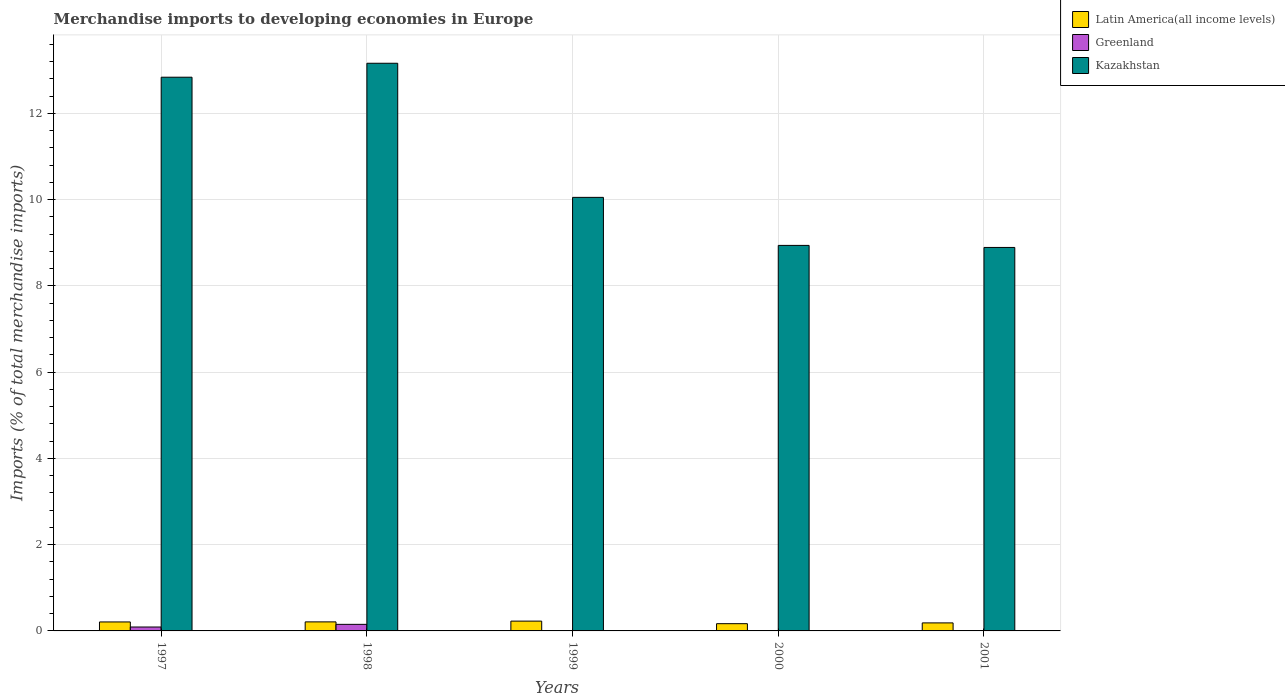Are the number of bars per tick equal to the number of legend labels?
Your response must be concise. Yes. Are the number of bars on each tick of the X-axis equal?
Your response must be concise. Yes. In how many cases, is the number of bars for a given year not equal to the number of legend labels?
Make the answer very short. 0. What is the percentage total merchandise imports in Kazakhstan in 2001?
Offer a terse response. 8.89. Across all years, what is the maximum percentage total merchandise imports in Greenland?
Your answer should be very brief. 0.15. Across all years, what is the minimum percentage total merchandise imports in Latin America(all income levels)?
Your response must be concise. 0.17. What is the total percentage total merchandise imports in Latin America(all income levels) in the graph?
Make the answer very short. 1. What is the difference between the percentage total merchandise imports in Latin America(all income levels) in 1997 and that in 2000?
Ensure brevity in your answer.  0.04. What is the difference between the percentage total merchandise imports in Kazakhstan in 1998 and the percentage total merchandise imports in Latin America(all income levels) in 1999?
Ensure brevity in your answer.  12.94. What is the average percentage total merchandise imports in Latin America(all income levels) per year?
Your answer should be compact. 0.2. In the year 1997, what is the difference between the percentage total merchandise imports in Kazakhstan and percentage total merchandise imports in Latin America(all income levels)?
Give a very brief answer. 12.63. What is the ratio of the percentage total merchandise imports in Kazakhstan in 1999 to that in 2001?
Give a very brief answer. 1.13. What is the difference between the highest and the second highest percentage total merchandise imports in Greenland?
Offer a terse response. 0.06. What is the difference between the highest and the lowest percentage total merchandise imports in Greenland?
Your answer should be compact. 0.15. What does the 3rd bar from the left in 1999 represents?
Offer a terse response. Kazakhstan. What does the 3rd bar from the right in 1999 represents?
Offer a terse response. Latin America(all income levels). How many bars are there?
Offer a very short reply. 15. How many years are there in the graph?
Offer a very short reply. 5. What is the difference between two consecutive major ticks on the Y-axis?
Make the answer very short. 2. Are the values on the major ticks of Y-axis written in scientific E-notation?
Your answer should be very brief. No. Does the graph contain grids?
Ensure brevity in your answer.  Yes. Where does the legend appear in the graph?
Provide a short and direct response. Top right. How many legend labels are there?
Ensure brevity in your answer.  3. How are the legend labels stacked?
Your response must be concise. Vertical. What is the title of the graph?
Make the answer very short. Merchandise imports to developing economies in Europe. What is the label or title of the X-axis?
Your response must be concise. Years. What is the label or title of the Y-axis?
Make the answer very short. Imports (% of total merchandise imports). What is the Imports (% of total merchandise imports) in Latin America(all income levels) in 1997?
Provide a short and direct response. 0.21. What is the Imports (% of total merchandise imports) of Greenland in 1997?
Ensure brevity in your answer.  0.09. What is the Imports (% of total merchandise imports) in Kazakhstan in 1997?
Your answer should be very brief. 12.84. What is the Imports (% of total merchandise imports) in Latin America(all income levels) in 1998?
Your answer should be compact. 0.21. What is the Imports (% of total merchandise imports) of Greenland in 1998?
Provide a short and direct response. 0.15. What is the Imports (% of total merchandise imports) of Kazakhstan in 1998?
Make the answer very short. 13.16. What is the Imports (% of total merchandise imports) in Latin America(all income levels) in 1999?
Your response must be concise. 0.23. What is the Imports (% of total merchandise imports) in Greenland in 1999?
Your response must be concise. 0. What is the Imports (% of total merchandise imports) of Kazakhstan in 1999?
Your response must be concise. 10.05. What is the Imports (% of total merchandise imports) of Latin America(all income levels) in 2000?
Provide a short and direct response. 0.17. What is the Imports (% of total merchandise imports) in Greenland in 2000?
Keep it short and to the point. 0. What is the Imports (% of total merchandise imports) of Kazakhstan in 2000?
Offer a terse response. 8.94. What is the Imports (% of total merchandise imports) of Latin America(all income levels) in 2001?
Provide a short and direct response. 0.19. What is the Imports (% of total merchandise imports) of Greenland in 2001?
Ensure brevity in your answer.  0. What is the Imports (% of total merchandise imports) of Kazakhstan in 2001?
Your answer should be very brief. 8.89. Across all years, what is the maximum Imports (% of total merchandise imports) in Latin America(all income levels)?
Your answer should be very brief. 0.23. Across all years, what is the maximum Imports (% of total merchandise imports) in Greenland?
Make the answer very short. 0.15. Across all years, what is the maximum Imports (% of total merchandise imports) of Kazakhstan?
Make the answer very short. 13.16. Across all years, what is the minimum Imports (% of total merchandise imports) in Latin America(all income levels)?
Your answer should be very brief. 0.17. Across all years, what is the minimum Imports (% of total merchandise imports) in Greenland?
Your response must be concise. 0. Across all years, what is the minimum Imports (% of total merchandise imports) in Kazakhstan?
Provide a succinct answer. 8.89. What is the total Imports (% of total merchandise imports) in Latin America(all income levels) in the graph?
Provide a short and direct response. 1. What is the total Imports (% of total merchandise imports) in Greenland in the graph?
Provide a succinct answer. 0.25. What is the total Imports (% of total merchandise imports) of Kazakhstan in the graph?
Your response must be concise. 53.89. What is the difference between the Imports (% of total merchandise imports) in Latin America(all income levels) in 1997 and that in 1998?
Offer a terse response. -0. What is the difference between the Imports (% of total merchandise imports) in Greenland in 1997 and that in 1998?
Give a very brief answer. -0.06. What is the difference between the Imports (% of total merchandise imports) of Kazakhstan in 1997 and that in 1998?
Your answer should be compact. -0.32. What is the difference between the Imports (% of total merchandise imports) of Latin America(all income levels) in 1997 and that in 1999?
Offer a terse response. -0.02. What is the difference between the Imports (% of total merchandise imports) of Greenland in 1997 and that in 1999?
Offer a terse response. 0.09. What is the difference between the Imports (% of total merchandise imports) in Kazakhstan in 1997 and that in 1999?
Keep it short and to the point. 2.79. What is the difference between the Imports (% of total merchandise imports) of Latin America(all income levels) in 1997 and that in 2000?
Give a very brief answer. 0.04. What is the difference between the Imports (% of total merchandise imports) of Greenland in 1997 and that in 2000?
Ensure brevity in your answer.  0.09. What is the difference between the Imports (% of total merchandise imports) of Kazakhstan in 1997 and that in 2000?
Your response must be concise. 3.9. What is the difference between the Imports (% of total merchandise imports) of Latin America(all income levels) in 1997 and that in 2001?
Provide a succinct answer. 0.02. What is the difference between the Imports (% of total merchandise imports) of Greenland in 1997 and that in 2001?
Your answer should be very brief. 0.09. What is the difference between the Imports (% of total merchandise imports) of Kazakhstan in 1997 and that in 2001?
Your answer should be very brief. 3.95. What is the difference between the Imports (% of total merchandise imports) in Latin America(all income levels) in 1998 and that in 1999?
Offer a terse response. -0.02. What is the difference between the Imports (% of total merchandise imports) of Greenland in 1998 and that in 1999?
Your answer should be compact. 0.15. What is the difference between the Imports (% of total merchandise imports) of Kazakhstan in 1998 and that in 1999?
Provide a succinct answer. 3.11. What is the difference between the Imports (% of total merchandise imports) of Latin America(all income levels) in 1998 and that in 2000?
Ensure brevity in your answer.  0.04. What is the difference between the Imports (% of total merchandise imports) of Kazakhstan in 1998 and that in 2000?
Make the answer very short. 4.22. What is the difference between the Imports (% of total merchandise imports) in Latin America(all income levels) in 1998 and that in 2001?
Ensure brevity in your answer.  0.02. What is the difference between the Imports (% of total merchandise imports) of Greenland in 1998 and that in 2001?
Keep it short and to the point. 0.15. What is the difference between the Imports (% of total merchandise imports) in Kazakhstan in 1998 and that in 2001?
Make the answer very short. 4.27. What is the difference between the Imports (% of total merchandise imports) of Latin America(all income levels) in 1999 and that in 2000?
Provide a succinct answer. 0.06. What is the difference between the Imports (% of total merchandise imports) of Greenland in 1999 and that in 2000?
Keep it short and to the point. 0. What is the difference between the Imports (% of total merchandise imports) of Kazakhstan in 1999 and that in 2000?
Make the answer very short. 1.11. What is the difference between the Imports (% of total merchandise imports) of Latin America(all income levels) in 1999 and that in 2001?
Ensure brevity in your answer.  0.04. What is the difference between the Imports (% of total merchandise imports) in Greenland in 1999 and that in 2001?
Your answer should be very brief. 0. What is the difference between the Imports (% of total merchandise imports) in Kazakhstan in 1999 and that in 2001?
Make the answer very short. 1.16. What is the difference between the Imports (% of total merchandise imports) of Latin America(all income levels) in 2000 and that in 2001?
Offer a very short reply. -0.02. What is the difference between the Imports (% of total merchandise imports) of Greenland in 2000 and that in 2001?
Your answer should be compact. -0. What is the difference between the Imports (% of total merchandise imports) of Kazakhstan in 2000 and that in 2001?
Ensure brevity in your answer.  0.05. What is the difference between the Imports (% of total merchandise imports) in Latin America(all income levels) in 1997 and the Imports (% of total merchandise imports) in Greenland in 1998?
Your answer should be very brief. 0.06. What is the difference between the Imports (% of total merchandise imports) of Latin America(all income levels) in 1997 and the Imports (% of total merchandise imports) of Kazakhstan in 1998?
Give a very brief answer. -12.95. What is the difference between the Imports (% of total merchandise imports) of Greenland in 1997 and the Imports (% of total merchandise imports) of Kazakhstan in 1998?
Give a very brief answer. -13.07. What is the difference between the Imports (% of total merchandise imports) in Latin America(all income levels) in 1997 and the Imports (% of total merchandise imports) in Greenland in 1999?
Provide a short and direct response. 0.2. What is the difference between the Imports (% of total merchandise imports) in Latin America(all income levels) in 1997 and the Imports (% of total merchandise imports) in Kazakhstan in 1999?
Provide a succinct answer. -9.84. What is the difference between the Imports (% of total merchandise imports) in Greenland in 1997 and the Imports (% of total merchandise imports) in Kazakhstan in 1999?
Make the answer very short. -9.96. What is the difference between the Imports (% of total merchandise imports) in Latin America(all income levels) in 1997 and the Imports (% of total merchandise imports) in Greenland in 2000?
Provide a short and direct response. 0.21. What is the difference between the Imports (% of total merchandise imports) in Latin America(all income levels) in 1997 and the Imports (% of total merchandise imports) in Kazakhstan in 2000?
Provide a succinct answer. -8.73. What is the difference between the Imports (% of total merchandise imports) of Greenland in 1997 and the Imports (% of total merchandise imports) of Kazakhstan in 2000?
Your answer should be compact. -8.85. What is the difference between the Imports (% of total merchandise imports) of Latin America(all income levels) in 1997 and the Imports (% of total merchandise imports) of Greenland in 2001?
Your response must be concise. 0.21. What is the difference between the Imports (% of total merchandise imports) in Latin America(all income levels) in 1997 and the Imports (% of total merchandise imports) in Kazakhstan in 2001?
Keep it short and to the point. -8.68. What is the difference between the Imports (% of total merchandise imports) of Greenland in 1997 and the Imports (% of total merchandise imports) of Kazakhstan in 2001?
Provide a succinct answer. -8.8. What is the difference between the Imports (% of total merchandise imports) of Latin America(all income levels) in 1998 and the Imports (% of total merchandise imports) of Greenland in 1999?
Provide a short and direct response. 0.21. What is the difference between the Imports (% of total merchandise imports) of Latin America(all income levels) in 1998 and the Imports (% of total merchandise imports) of Kazakhstan in 1999?
Your answer should be very brief. -9.84. What is the difference between the Imports (% of total merchandise imports) in Greenland in 1998 and the Imports (% of total merchandise imports) in Kazakhstan in 1999?
Your answer should be very brief. -9.9. What is the difference between the Imports (% of total merchandise imports) of Latin America(all income levels) in 1998 and the Imports (% of total merchandise imports) of Greenland in 2000?
Ensure brevity in your answer.  0.21. What is the difference between the Imports (% of total merchandise imports) in Latin America(all income levels) in 1998 and the Imports (% of total merchandise imports) in Kazakhstan in 2000?
Your answer should be compact. -8.73. What is the difference between the Imports (% of total merchandise imports) of Greenland in 1998 and the Imports (% of total merchandise imports) of Kazakhstan in 2000?
Your answer should be compact. -8.79. What is the difference between the Imports (% of total merchandise imports) in Latin America(all income levels) in 1998 and the Imports (% of total merchandise imports) in Greenland in 2001?
Keep it short and to the point. 0.21. What is the difference between the Imports (% of total merchandise imports) in Latin America(all income levels) in 1998 and the Imports (% of total merchandise imports) in Kazakhstan in 2001?
Offer a terse response. -8.68. What is the difference between the Imports (% of total merchandise imports) in Greenland in 1998 and the Imports (% of total merchandise imports) in Kazakhstan in 2001?
Provide a succinct answer. -8.74. What is the difference between the Imports (% of total merchandise imports) in Latin America(all income levels) in 1999 and the Imports (% of total merchandise imports) in Greenland in 2000?
Provide a succinct answer. 0.23. What is the difference between the Imports (% of total merchandise imports) of Latin America(all income levels) in 1999 and the Imports (% of total merchandise imports) of Kazakhstan in 2000?
Provide a succinct answer. -8.71. What is the difference between the Imports (% of total merchandise imports) in Greenland in 1999 and the Imports (% of total merchandise imports) in Kazakhstan in 2000?
Give a very brief answer. -8.94. What is the difference between the Imports (% of total merchandise imports) of Latin America(all income levels) in 1999 and the Imports (% of total merchandise imports) of Greenland in 2001?
Your response must be concise. 0.22. What is the difference between the Imports (% of total merchandise imports) of Latin America(all income levels) in 1999 and the Imports (% of total merchandise imports) of Kazakhstan in 2001?
Offer a very short reply. -8.66. What is the difference between the Imports (% of total merchandise imports) in Greenland in 1999 and the Imports (% of total merchandise imports) in Kazakhstan in 2001?
Offer a very short reply. -8.89. What is the difference between the Imports (% of total merchandise imports) of Latin America(all income levels) in 2000 and the Imports (% of total merchandise imports) of Greenland in 2001?
Your answer should be compact. 0.17. What is the difference between the Imports (% of total merchandise imports) in Latin America(all income levels) in 2000 and the Imports (% of total merchandise imports) in Kazakhstan in 2001?
Ensure brevity in your answer.  -8.72. What is the difference between the Imports (% of total merchandise imports) in Greenland in 2000 and the Imports (% of total merchandise imports) in Kazakhstan in 2001?
Ensure brevity in your answer.  -8.89. What is the average Imports (% of total merchandise imports) in Latin America(all income levels) per year?
Provide a succinct answer. 0.2. What is the average Imports (% of total merchandise imports) of Greenland per year?
Offer a very short reply. 0.05. What is the average Imports (% of total merchandise imports) of Kazakhstan per year?
Offer a terse response. 10.78. In the year 1997, what is the difference between the Imports (% of total merchandise imports) in Latin America(all income levels) and Imports (% of total merchandise imports) in Greenland?
Make the answer very short. 0.12. In the year 1997, what is the difference between the Imports (% of total merchandise imports) in Latin America(all income levels) and Imports (% of total merchandise imports) in Kazakhstan?
Provide a succinct answer. -12.63. In the year 1997, what is the difference between the Imports (% of total merchandise imports) in Greenland and Imports (% of total merchandise imports) in Kazakhstan?
Make the answer very short. -12.75. In the year 1998, what is the difference between the Imports (% of total merchandise imports) in Latin America(all income levels) and Imports (% of total merchandise imports) in Greenland?
Your answer should be very brief. 0.06. In the year 1998, what is the difference between the Imports (% of total merchandise imports) in Latin America(all income levels) and Imports (% of total merchandise imports) in Kazakhstan?
Ensure brevity in your answer.  -12.95. In the year 1998, what is the difference between the Imports (% of total merchandise imports) of Greenland and Imports (% of total merchandise imports) of Kazakhstan?
Ensure brevity in your answer.  -13.01. In the year 1999, what is the difference between the Imports (% of total merchandise imports) in Latin America(all income levels) and Imports (% of total merchandise imports) in Greenland?
Provide a succinct answer. 0.22. In the year 1999, what is the difference between the Imports (% of total merchandise imports) in Latin America(all income levels) and Imports (% of total merchandise imports) in Kazakhstan?
Your answer should be compact. -9.83. In the year 1999, what is the difference between the Imports (% of total merchandise imports) in Greenland and Imports (% of total merchandise imports) in Kazakhstan?
Ensure brevity in your answer.  -10.05. In the year 2000, what is the difference between the Imports (% of total merchandise imports) of Latin America(all income levels) and Imports (% of total merchandise imports) of Greenland?
Provide a short and direct response. 0.17. In the year 2000, what is the difference between the Imports (% of total merchandise imports) of Latin America(all income levels) and Imports (% of total merchandise imports) of Kazakhstan?
Provide a succinct answer. -8.77. In the year 2000, what is the difference between the Imports (% of total merchandise imports) in Greenland and Imports (% of total merchandise imports) in Kazakhstan?
Provide a succinct answer. -8.94. In the year 2001, what is the difference between the Imports (% of total merchandise imports) of Latin America(all income levels) and Imports (% of total merchandise imports) of Greenland?
Offer a terse response. 0.18. In the year 2001, what is the difference between the Imports (% of total merchandise imports) in Latin America(all income levels) and Imports (% of total merchandise imports) in Kazakhstan?
Ensure brevity in your answer.  -8.71. In the year 2001, what is the difference between the Imports (% of total merchandise imports) of Greenland and Imports (% of total merchandise imports) of Kazakhstan?
Offer a very short reply. -8.89. What is the ratio of the Imports (% of total merchandise imports) in Latin America(all income levels) in 1997 to that in 1998?
Keep it short and to the point. 0.99. What is the ratio of the Imports (% of total merchandise imports) in Greenland in 1997 to that in 1998?
Offer a very short reply. 0.6. What is the ratio of the Imports (% of total merchandise imports) in Kazakhstan in 1997 to that in 1998?
Keep it short and to the point. 0.98. What is the ratio of the Imports (% of total merchandise imports) of Latin America(all income levels) in 1997 to that in 1999?
Your response must be concise. 0.91. What is the ratio of the Imports (% of total merchandise imports) of Greenland in 1997 to that in 1999?
Offer a terse response. 21.65. What is the ratio of the Imports (% of total merchandise imports) of Kazakhstan in 1997 to that in 1999?
Keep it short and to the point. 1.28. What is the ratio of the Imports (% of total merchandise imports) of Latin America(all income levels) in 1997 to that in 2000?
Your answer should be compact. 1.24. What is the ratio of the Imports (% of total merchandise imports) in Greenland in 1997 to that in 2000?
Keep it short and to the point. 37.03. What is the ratio of the Imports (% of total merchandise imports) of Kazakhstan in 1997 to that in 2000?
Give a very brief answer. 1.44. What is the ratio of the Imports (% of total merchandise imports) of Latin America(all income levels) in 1997 to that in 2001?
Keep it short and to the point. 1.12. What is the ratio of the Imports (% of total merchandise imports) in Greenland in 1997 to that in 2001?
Offer a very short reply. 34.31. What is the ratio of the Imports (% of total merchandise imports) of Kazakhstan in 1997 to that in 2001?
Make the answer very short. 1.44. What is the ratio of the Imports (% of total merchandise imports) in Latin America(all income levels) in 1998 to that in 1999?
Your answer should be very brief. 0.92. What is the ratio of the Imports (% of total merchandise imports) in Greenland in 1998 to that in 1999?
Your answer should be very brief. 36.33. What is the ratio of the Imports (% of total merchandise imports) of Kazakhstan in 1998 to that in 1999?
Make the answer very short. 1.31. What is the ratio of the Imports (% of total merchandise imports) in Latin America(all income levels) in 1998 to that in 2000?
Offer a very short reply. 1.25. What is the ratio of the Imports (% of total merchandise imports) of Greenland in 1998 to that in 2000?
Your answer should be compact. 62.14. What is the ratio of the Imports (% of total merchandise imports) of Kazakhstan in 1998 to that in 2000?
Give a very brief answer. 1.47. What is the ratio of the Imports (% of total merchandise imports) in Latin America(all income levels) in 1998 to that in 2001?
Your answer should be compact. 1.13. What is the ratio of the Imports (% of total merchandise imports) of Greenland in 1998 to that in 2001?
Make the answer very short. 57.58. What is the ratio of the Imports (% of total merchandise imports) of Kazakhstan in 1998 to that in 2001?
Provide a succinct answer. 1.48. What is the ratio of the Imports (% of total merchandise imports) in Latin America(all income levels) in 1999 to that in 2000?
Your response must be concise. 1.36. What is the ratio of the Imports (% of total merchandise imports) of Greenland in 1999 to that in 2000?
Provide a short and direct response. 1.71. What is the ratio of the Imports (% of total merchandise imports) in Kazakhstan in 1999 to that in 2000?
Offer a very short reply. 1.12. What is the ratio of the Imports (% of total merchandise imports) in Latin America(all income levels) in 1999 to that in 2001?
Offer a very short reply. 1.22. What is the ratio of the Imports (% of total merchandise imports) of Greenland in 1999 to that in 2001?
Make the answer very short. 1.58. What is the ratio of the Imports (% of total merchandise imports) of Kazakhstan in 1999 to that in 2001?
Offer a terse response. 1.13. What is the ratio of the Imports (% of total merchandise imports) of Latin America(all income levels) in 2000 to that in 2001?
Keep it short and to the point. 0.9. What is the ratio of the Imports (% of total merchandise imports) in Greenland in 2000 to that in 2001?
Make the answer very short. 0.93. What is the ratio of the Imports (% of total merchandise imports) of Kazakhstan in 2000 to that in 2001?
Your response must be concise. 1.01. What is the difference between the highest and the second highest Imports (% of total merchandise imports) in Latin America(all income levels)?
Your response must be concise. 0.02. What is the difference between the highest and the second highest Imports (% of total merchandise imports) of Greenland?
Provide a short and direct response. 0.06. What is the difference between the highest and the second highest Imports (% of total merchandise imports) of Kazakhstan?
Ensure brevity in your answer.  0.32. What is the difference between the highest and the lowest Imports (% of total merchandise imports) of Latin America(all income levels)?
Keep it short and to the point. 0.06. What is the difference between the highest and the lowest Imports (% of total merchandise imports) in Kazakhstan?
Provide a short and direct response. 4.27. 